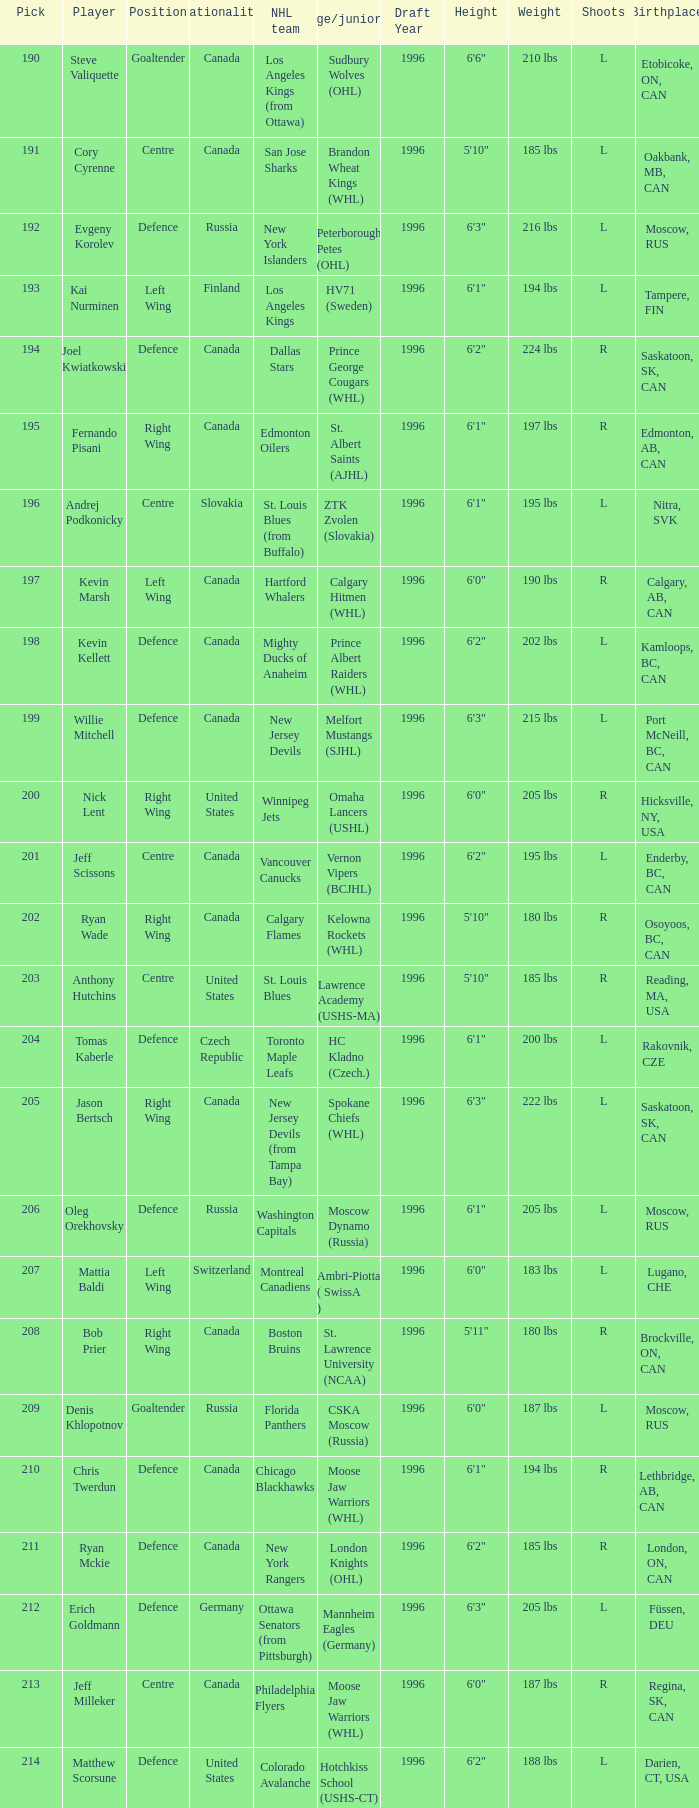Name the number of nationalities for ryan mckie 1.0. 